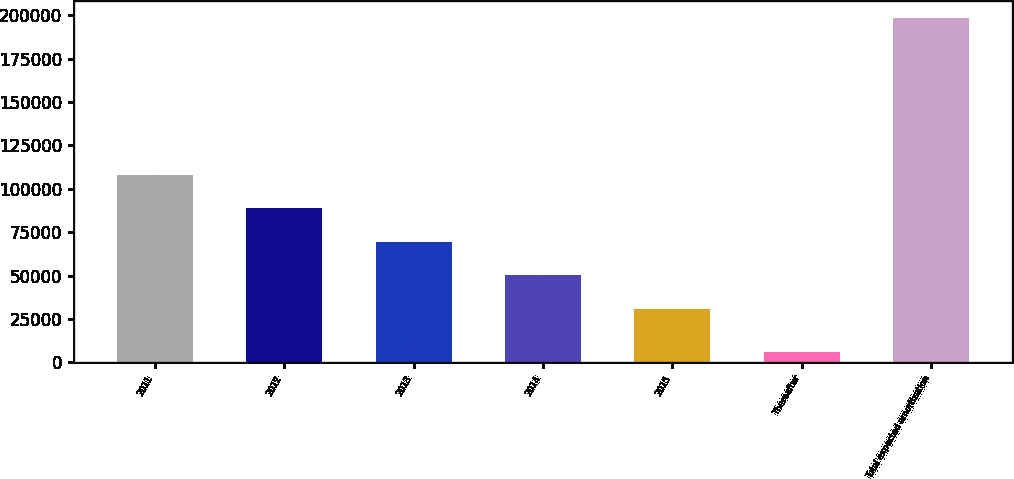Convert chart to OTSL. <chart><loc_0><loc_0><loc_500><loc_500><bar_chart><fcel>2011<fcel>2012<fcel>2013<fcel>2014<fcel>2015<fcel>Thereafter<fcel>Total expected amortization<nl><fcel>107912<fcel>88668.5<fcel>69425<fcel>50181.5<fcel>30938<fcel>5776<fcel>198211<nl></chart> 